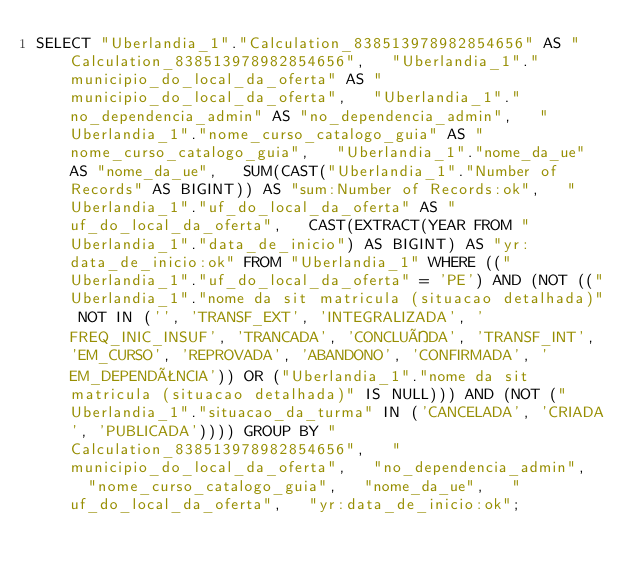<code> <loc_0><loc_0><loc_500><loc_500><_SQL_>SELECT "Uberlandia_1"."Calculation_838513978982854656" AS "Calculation_838513978982854656",   "Uberlandia_1"."municipio_do_local_da_oferta" AS "municipio_do_local_da_oferta",   "Uberlandia_1"."no_dependencia_admin" AS "no_dependencia_admin",   "Uberlandia_1"."nome_curso_catalogo_guia" AS "nome_curso_catalogo_guia",   "Uberlandia_1"."nome_da_ue" AS "nome_da_ue",   SUM(CAST("Uberlandia_1"."Number of Records" AS BIGINT)) AS "sum:Number of Records:ok",   "Uberlandia_1"."uf_do_local_da_oferta" AS "uf_do_local_da_oferta",   CAST(EXTRACT(YEAR FROM "Uberlandia_1"."data_de_inicio") AS BIGINT) AS "yr:data_de_inicio:ok" FROM "Uberlandia_1" WHERE (("Uberlandia_1"."uf_do_local_da_oferta" = 'PE') AND (NOT (("Uberlandia_1"."nome da sit matricula (situacao detalhada)" NOT IN ('', 'TRANSF_EXT', 'INTEGRALIZADA', 'FREQ_INIC_INSUF', 'TRANCADA', 'CONCLUÍDA', 'TRANSF_INT', 'EM_CURSO', 'REPROVADA', 'ABANDONO', 'CONFIRMADA', 'EM_DEPENDÊNCIA')) OR ("Uberlandia_1"."nome da sit matricula (situacao detalhada)" IS NULL))) AND (NOT ("Uberlandia_1"."situacao_da_turma" IN ('CANCELADA', 'CRIADA', 'PUBLICADA')))) GROUP BY "Calculation_838513978982854656",   "municipio_do_local_da_oferta",   "no_dependencia_admin",   "nome_curso_catalogo_guia",   "nome_da_ue",   "uf_do_local_da_oferta",   "yr:data_de_inicio:ok";
</code> 